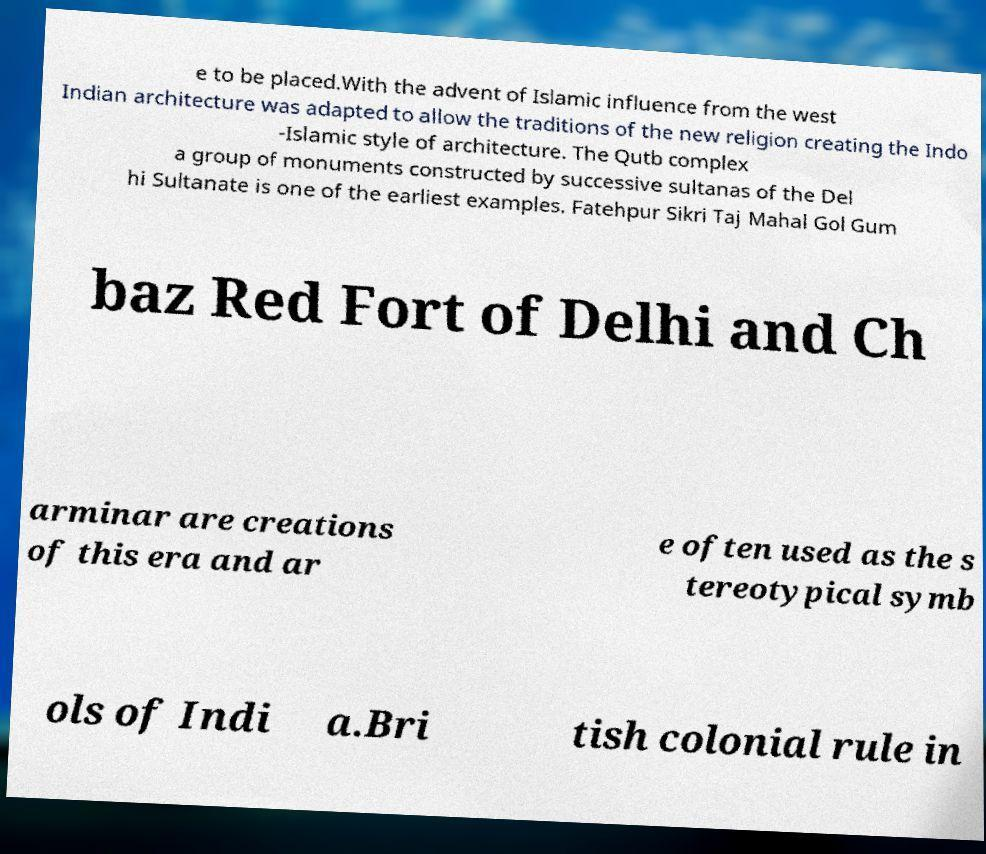For documentation purposes, I need the text within this image transcribed. Could you provide that? e to be placed.With the advent of Islamic influence from the west Indian architecture was adapted to allow the traditions of the new religion creating the Indo -Islamic style of architecture. The Qutb complex a group of monuments constructed by successive sultanas of the Del hi Sultanate is one of the earliest examples. Fatehpur Sikri Taj Mahal Gol Gum baz Red Fort of Delhi and Ch arminar are creations of this era and ar e often used as the s tereotypical symb ols of Indi a.Bri tish colonial rule in 